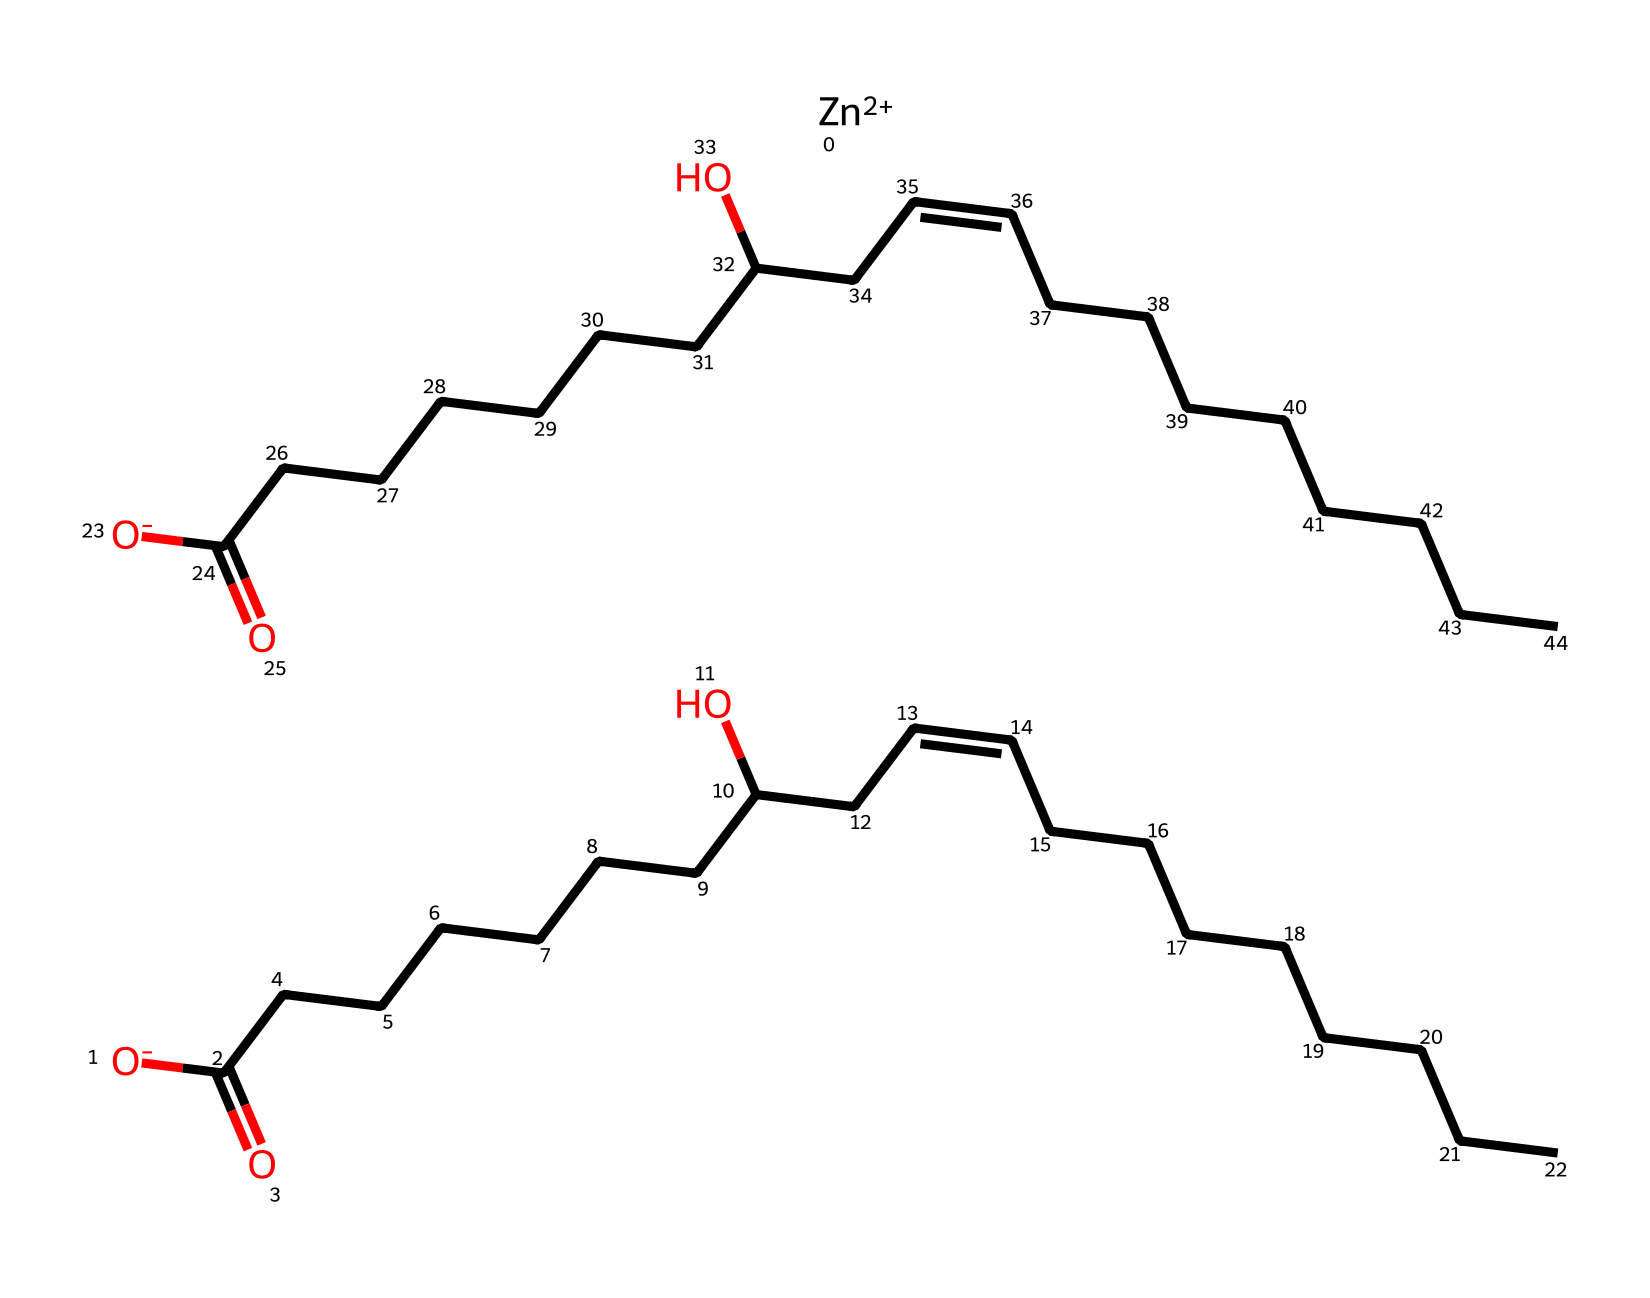What is the main functional group present in this chemical? The chemical contains multiple carboxylic acid functional groups, identified by the presence of carbonyl (C=O) attached to a hydroxyl group (O-). This is evidenced by the repeated structure "C(=O)O" in the SMILES representation.
Answer: carboxylic acid How many carbon atoms are in the longest carbon chain of this compound? The longest carbon chain in the compound includes multiple segments. By counting the chain represented in the sequence of "CCCCCCC" in the SMILES notation, we find that the longest chain consists of 7 carbon atoms.
Answer: seven What type of bonding is likely to exist between the sulfur compound and odor molecules? Sulfur compounds can interact with odor molecules through a combination of hydrogen bonding and van der Waals interactions. The presence of hydroxyl (OH) groups facilitates hydrogen bonding while the carbon chains allow for van der Waals interactions.
Answer: hydrogen bonding Which metal ion is involved in the composition of this chemical? The SMILES representation indicates the presence of a zinc ion, denoted by the symbol "Zn++" at the beginning of the SMILES.
Answer: zinc How many unique carboxylic acid groups are present in the SMILES structure? By analyzing the SMILES notation, we see two distinct instances of the carboxylic acid functional group "C(=O)O," indicating there are two unique carboxylic acid groups in the structure.
Answer: two What characteristic property do sulfur compounds impart in odor neutralizers? Sulfur compounds are known for their ability to neutralize odors through chemical reactions that lead to the capture and transformation of volatile sulfur-containing odor molecules into non-volatile or less odorous forms.
Answer: neutralization of odors 